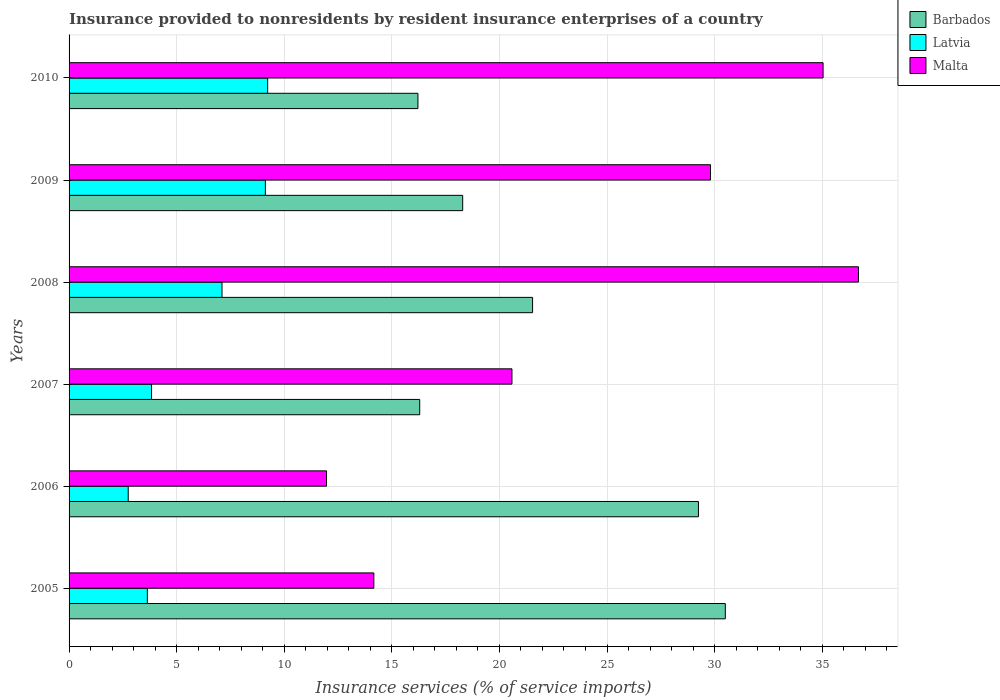How many different coloured bars are there?
Offer a terse response. 3. What is the insurance provided to nonresidents in Barbados in 2005?
Your response must be concise. 30.5. Across all years, what is the maximum insurance provided to nonresidents in Latvia?
Provide a succinct answer. 9.23. Across all years, what is the minimum insurance provided to nonresidents in Malta?
Keep it short and to the point. 11.96. What is the total insurance provided to nonresidents in Barbados in the graph?
Your answer should be compact. 132.09. What is the difference between the insurance provided to nonresidents in Malta in 2009 and that in 2010?
Provide a short and direct response. -5.23. What is the difference between the insurance provided to nonresidents in Latvia in 2008 and the insurance provided to nonresidents in Malta in 2007?
Offer a very short reply. -13.48. What is the average insurance provided to nonresidents in Barbados per year?
Your answer should be compact. 22.01. In the year 2005, what is the difference between the insurance provided to nonresidents in Barbados and insurance provided to nonresidents in Latvia?
Your answer should be very brief. 26.86. What is the ratio of the insurance provided to nonresidents in Malta in 2006 to that in 2008?
Your response must be concise. 0.33. Is the insurance provided to nonresidents in Malta in 2005 less than that in 2006?
Give a very brief answer. No. Is the difference between the insurance provided to nonresidents in Barbados in 2006 and 2010 greater than the difference between the insurance provided to nonresidents in Latvia in 2006 and 2010?
Keep it short and to the point. Yes. What is the difference between the highest and the second highest insurance provided to nonresidents in Malta?
Provide a succinct answer. 1.64. What is the difference between the highest and the lowest insurance provided to nonresidents in Latvia?
Ensure brevity in your answer.  6.48. In how many years, is the insurance provided to nonresidents in Barbados greater than the average insurance provided to nonresidents in Barbados taken over all years?
Offer a very short reply. 2. Is the sum of the insurance provided to nonresidents in Malta in 2006 and 2009 greater than the maximum insurance provided to nonresidents in Latvia across all years?
Your answer should be compact. Yes. What does the 2nd bar from the top in 2009 represents?
Make the answer very short. Latvia. What does the 1st bar from the bottom in 2010 represents?
Your response must be concise. Barbados. Is it the case that in every year, the sum of the insurance provided to nonresidents in Barbados and insurance provided to nonresidents in Malta is greater than the insurance provided to nonresidents in Latvia?
Make the answer very short. Yes. Are all the bars in the graph horizontal?
Make the answer very short. Yes. What is the difference between two consecutive major ticks on the X-axis?
Provide a short and direct response. 5. Does the graph contain any zero values?
Offer a terse response. No. Where does the legend appear in the graph?
Offer a terse response. Top right. How many legend labels are there?
Your response must be concise. 3. How are the legend labels stacked?
Offer a very short reply. Vertical. What is the title of the graph?
Offer a terse response. Insurance provided to nonresidents by resident insurance enterprises of a country. What is the label or title of the X-axis?
Make the answer very short. Insurance services (% of service imports). What is the label or title of the Y-axis?
Offer a terse response. Years. What is the Insurance services (% of service imports) of Barbados in 2005?
Offer a terse response. 30.5. What is the Insurance services (% of service imports) in Latvia in 2005?
Make the answer very short. 3.64. What is the Insurance services (% of service imports) of Malta in 2005?
Your answer should be compact. 14.16. What is the Insurance services (% of service imports) of Barbados in 2006?
Provide a succinct answer. 29.25. What is the Insurance services (% of service imports) in Latvia in 2006?
Your response must be concise. 2.75. What is the Insurance services (% of service imports) of Malta in 2006?
Your answer should be very brief. 11.96. What is the Insurance services (% of service imports) of Barbados in 2007?
Your answer should be very brief. 16.3. What is the Insurance services (% of service imports) of Latvia in 2007?
Keep it short and to the point. 3.83. What is the Insurance services (% of service imports) of Malta in 2007?
Your answer should be compact. 20.58. What is the Insurance services (% of service imports) of Barbados in 2008?
Your answer should be very brief. 21.54. What is the Insurance services (% of service imports) in Latvia in 2008?
Ensure brevity in your answer.  7.11. What is the Insurance services (% of service imports) in Malta in 2008?
Offer a very short reply. 36.69. What is the Insurance services (% of service imports) of Barbados in 2009?
Your response must be concise. 18.29. What is the Insurance services (% of service imports) in Latvia in 2009?
Offer a very short reply. 9.12. What is the Insurance services (% of service imports) of Malta in 2009?
Your answer should be compact. 29.81. What is the Insurance services (% of service imports) in Barbados in 2010?
Provide a short and direct response. 16.21. What is the Insurance services (% of service imports) of Latvia in 2010?
Give a very brief answer. 9.23. What is the Insurance services (% of service imports) in Malta in 2010?
Your response must be concise. 35.04. Across all years, what is the maximum Insurance services (% of service imports) of Barbados?
Your answer should be very brief. 30.5. Across all years, what is the maximum Insurance services (% of service imports) of Latvia?
Your answer should be compact. 9.23. Across all years, what is the maximum Insurance services (% of service imports) of Malta?
Keep it short and to the point. 36.69. Across all years, what is the minimum Insurance services (% of service imports) of Barbados?
Offer a very short reply. 16.21. Across all years, what is the minimum Insurance services (% of service imports) of Latvia?
Your response must be concise. 2.75. Across all years, what is the minimum Insurance services (% of service imports) in Malta?
Ensure brevity in your answer.  11.96. What is the total Insurance services (% of service imports) in Barbados in the graph?
Ensure brevity in your answer.  132.09. What is the total Insurance services (% of service imports) of Latvia in the graph?
Give a very brief answer. 35.68. What is the total Insurance services (% of service imports) in Malta in the graph?
Make the answer very short. 148.25. What is the difference between the Insurance services (% of service imports) of Barbados in 2005 and that in 2006?
Your answer should be very brief. 1.25. What is the difference between the Insurance services (% of service imports) of Latvia in 2005 and that in 2006?
Your answer should be very brief. 0.89. What is the difference between the Insurance services (% of service imports) in Malta in 2005 and that in 2006?
Your answer should be very brief. 2.2. What is the difference between the Insurance services (% of service imports) in Barbados in 2005 and that in 2007?
Offer a terse response. 14.2. What is the difference between the Insurance services (% of service imports) of Latvia in 2005 and that in 2007?
Keep it short and to the point. -0.2. What is the difference between the Insurance services (% of service imports) of Malta in 2005 and that in 2007?
Offer a terse response. -6.42. What is the difference between the Insurance services (% of service imports) in Barbados in 2005 and that in 2008?
Ensure brevity in your answer.  8.96. What is the difference between the Insurance services (% of service imports) of Latvia in 2005 and that in 2008?
Your answer should be compact. -3.47. What is the difference between the Insurance services (% of service imports) in Malta in 2005 and that in 2008?
Ensure brevity in your answer.  -22.52. What is the difference between the Insurance services (% of service imports) in Barbados in 2005 and that in 2009?
Your answer should be very brief. 12.21. What is the difference between the Insurance services (% of service imports) in Latvia in 2005 and that in 2009?
Ensure brevity in your answer.  -5.49. What is the difference between the Insurance services (% of service imports) in Malta in 2005 and that in 2009?
Keep it short and to the point. -15.64. What is the difference between the Insurance services (% of service imports) of Barbados in 2005 and that in 2010?
Give a very brief answer. 14.28. What is the difference between the Insurance services (% of service imports) of Latvia in 2005 and that in 2010?
Your answer should be compact. -5.59. What is the difference between the Insurance services (% of service imports) of Malta in 2005 and that in 2010?
Your answer should be very brief. -20.88. What is the difference between the Insurance services (% of service imports) of Barbados in 2006 and that in 2007?
Your answer should be very brief. 12.95. What is the difference between the Insurance services (% of service imports) of Latvia in 2006 and that in 2007?
Ensure brevity in your answer.  -1.08. What is the difference between the Insurance services (% of service imports) in Malta in 2006 and that in 2007?
Keep it short and to the point. -8.62. What is the difference between the Insurance services (% of service imports) of Barbados in 2006 and that in 2008?
Give a very brief answer. 7.71. What is the difference between the Insurance services (% of service imports) of Latvia in 2006 and that in 2008?
Keep it short and to the point. -4.36. What is the difference between the Insurance services (% of service imports) in Malta in 2006 and that in 2008?
Offer a terse response. -24.72. What is the difference between the Insurance services (% of service imports) in Barbados in 2006 and that in 2009?
Give a very brief answer. 10.96. What is the difference between the Insurance services (% of service imports) of Latvia in 2006 and that in 2009?
Keep it short and to the point. -6.37. What is the difference between the Insurance services (% of service imports) of Malta in 2006 and that in 2009?
Your answer should be very brief. -17.84. What is the difference between the Insurance services (% of service imports) in Barbados in 2006 and that in 2010?
Provide a succinct answer. 13.04. What is the difference between the Insurance services (% of service imports) in Latvia in 2006 and that in 2010?
Ensure brevity in your answer.  -6.48. What is the difference between the Insurance services (% of service imports) in Malta in 2006 and that in 2010?
Provide a short and direct response. -23.08. What is the difference between the Insurance services (% of service imports) of Barbados in 2007 and that in 2008?
Ensure brevity in your answer.  -5.24. What is the difference between the Insurance services (% of service imports) in Latvia in 2007 and that in 2008?
Give a very brief answer. -3.27. What is the difference between the Insurance services (% of service imports) in Malta in 2007 and that in 2008?
Ensure brevity in your answer.  -16.1. What is the difference between the Insurance services (% of service imports) in Barbados in 2007 and that in 2009?
Ensure brevity in your answer.  -2. What is the difference between the Insurance services (% of service imports) in Latvia in 2007 and that in 2009?
Your answer should be compact. -5.29. What is the difference between the Insurance services (% of service imports) of Malta in 2007 and that in 2009?
Offer a terse response. -9.23. What is the difference between the Insurance services (% of service imports) in Barbados in 2007 and that in 2010?
Your response must be concise. 0.08. What is the difference between the Insurance services (% of service imports) of Latvia in 2007 and that in 2010?
Your answer should be very brief. -5.4. What is the difference between the Insurance services (% of service imports) of Malta in 2007 and that in 2010?
Ensure brevity in your answer.  -14.46. What is the difference between the Insurance services (% of service imports) of Barbados in 2008 and that in 2009?
Give a very brief answer. 3.25. What is the difference between the Insurance services (% of service imports) in Latvia in 2008 and that in 2009?
Give a very brief answer. -2.02. What is the difference between the Insurance services (% of service imports) of Malta in 2008 and that in 2009?
Ensure brevity in your answer.  6.88. What is the difference between the Insurance services (% of service imports) in Barbados in 2008 and that in 2010?
Your response must be concise. 5.33. What is the difference between the Insurance services (% of service imports) of Latvia in 2008 and that in 2010?
Provide a succinct answer. -2.12. What is the difference between the Insurance services (% of service imports) of Malta in 2008 and that in 2010?
Make the answer very short. 1.64. What is the difference between the Insurance services (% of service imports) of Barbados in 2009 and that in 2010?
Give a very brief answer. 2.08. What is the difference between the Insurance services (% of service imports) in Latvia in 2009 and that in 2010?
Your answer should be very brief. -0.11. What is the difference between the Insurance services (% of service imports) in Malta in 2009 and that in 2010?
Your answer should be very brief. -5.23. What is the difference between the Insurance services (% of service imports) in Barbados in 2005 and the Insurance services (% of service imports) in Latvia in 2006?
Provide a succinct answer. 27.75. What is the difference between the Insurance services (% of service imports) in Barbados in 2005 and the Insurance services (% of service imports) in Malta in 2006?
Your answer should be very brief. 18.53. What is the difference between the Insurance services (% of service imports) in Latvia in 2005 and the Insurance services (% of service imports) in Malta in 2006?
Make the answer very short. -8.33. What is the difference between the Insurance services (% of service imports) of Barbados in 2005 and the Insurance services (% of service imports) of Latvia in 2007?
Your answer should be compact. 26.67. What is the difference between the Insurance services (% of service imports) of Barbados in 2005 and the Insurance services (% of service imports) of Malta in 2007?
Provide a short and direct response. 9.92. What is the difference between the Insurance services (% of service imports) of Latvia in 2005 and the Insurance services (% of service imports) of Malta in 2007?
Make the answer very short. -16.94. What is the difference between the Insurance services (% of service imports) of Barbados in 2005 and the Insurance services (% of service imports) of Latvia in 2008?
Your answer should be very brief. 23.39. What is the difference between the Insurance services (% of service imports) of Barbados in 2005 and the Insurance services (% of service imports) of Malta in 2008?
Your response must be concise. -6.19. What is the difference between the Insurance services (% of service imports) in Latvia in 2005 and the Insurance services (% of service imports) in Malta in 2008?
Offer a very short reply. -33.05. What is the difference between the Insurance services (% of service imports) in Barbados in 2005 and the Insurance services (% of service imports) in Latvia in 2009?
Make the answer very short. 21.38. What is the difference between the Insurance services (% of service imports) of Barbados in 2005 and the Insurance services (% of service imports) of Malta in 2009?
Your answer should be compact. 0.69. What is the difference between the Insurance services (% of service imports) in Latvia in 2005 and the Insurance services (% of service imports) in Malta in 2009?
Provide a succinct answer. -26.17. What is the difference between the Insurance services (% of service imports) in Barbados in 2005 and the Insurance services (% of service imports) in Latvia in 2010?
Provide a succinct answer. 21.27. What is the difference between the Insurance services (% of service imports) in Barbados in 2005 and the Insurance services (% of service imports) in Malta in 2010?
Your answer should be very brief. -4.54. What is the difference between the Insurance services (% of service imports) in Latvia in 2005 and the Insurance services (% of service imports) in Malta in 2010?
Ensure brevity in your answer.  -31.4. What is the difference between the Insurance services (% of service imports) of Barbados in 2006 and the Insurance services (% of service imports) of Latvia in 2007?
Provide a short and direct response. 25.42. What is the difference between the Insurance services (% of service imports) in Barbados in 2006 and the Insurance services (% of service imports) in Malta in 2007?
Your answer should be very brief. 8.67. What is the difference between the Insurance services (% of service imports) in Latvia in 2006 and the Insurance services (% of service imports) in Malta in 2007?
Offer a terse response. -17.83. What is the difference between the Insurance services (% of service imports) in Barbados in 2006 and the Insurance services (% of service imports) in Latvia in 2008?
Your answer should be very brief. 22.14. What is the difference between the Insurance services (% of service imports) in Barbados in 2006 and the Insurance services (% of service imports) in Malta in 2008?
Provide a succinct answer. -7.44. What is the difference between the Insurance services (% of service imports) of Latvia in 2006 and the Insurance services (% of service imports) of Malta in 2008?
Give a very brief answer. -33.94. What is the difference between the Insurance services (% of service imports) in Barbados in 2006 and the Insurance services (% of service imports) in Latvia in 2009?
Your answer should be very brief. 20.13. What is the difference between the Insurance services (% of service imports) in Barbados in 2006 and the Insurance services (% of service imports) in Malta in 2009?
Your answer should be compact. -0.56. What is the difference between the Insurance services (% of service imports) of Latvia in 2006 and the Insurance services (% of service imports) of Malta in 2009?
Your response must be concise. -27.06. What is the difference between the Insurance services (% of service imports) in Barbados in 2006 and the Insurance services (% of service imports) in Latvia in 2010?
Give a very brief answer. 20.02. What is the difference between the Insurance services (% of service imports) in Barbados in 2006 and the Insurance services (% of service imports) in Malta in 2010?
Provide a short and direct response. -5.79. What is the difference between the Insurance services (% of service imports) of Latvia in 2006 and the Insurance services (% of service imports) of Malta in 2010?
Give a very brief answer. -32.29. What is the difference between the Insurance services (% of service imports) in Barbados in 2007 and the Insurance services (% of service imports) in Latvia in 2008?
Offer a terse response. 9.19. What is the difference between the Insurance services (% of service imports) in Barbados in 2007 and the Insurance services (% of service imports) in Malta in 2008?
Provide a succinct answer. -20.39. What is the difference between the Insurance services (% of service imports) in Latvia in 2007 and the Insurance services (% of service imports) in Malta in 2008?
Keep it short and to the point. -32.85. What is the difference between the Insurance services (% of service imports) of Barbados in 2007 and the Insurance services (% of service imports) of Latvia in 2009?
Provide a short and direct response. 7.17. What is the difference between the Insurance services (% of service imports) of Barbados in 2007 and the Insurance services (% of service imports) of Malta in 2009?
Provide a short and direct response. -13.51. What is the difference between the Insurance services (% of service imports) of Latvia in 2007 and the Insurance services (% of service imports) of Malta in 2009?
Ensure brevity in your answer.  -25.98. What is the difference between the Insurance services (% of service imports) in Barbados in 2007 and the Insurance services (% of service imports) in Latvia in 2010?
Provide a short and direct response. 7.07. What is the difference between the Insurance services (% of service imports) of Barbados in 2007 and the Insurance services (% of service imports) of Malta in 2010?
Give a very brief answer. -18.75. What is the difference between the Insurance services (% of service imports) in Latvia in 2007 and the Insurance services (% of service imports) in Malta in 2010?
Your response must be concise. -31.21. What is the difference between the Insurance services (% of service imports) of Barbados in 2008 and the Insurance services (% of service imports) of Latvia in 2009?
Your response must be concise. 12.42. What is the difference between the Insurance services (% of service imports) in Barbados in 2008 and the Insurance services (% of service imports) in Malta in 2009?
Provide a succinct answer. -8.27. What is the difference between the Insurance services (% of service imports) of Latvia in 2008 and the Insurance services (% of service imports) of Malta in 2009?
Provide a succinct answer. -22.7. What is the difference between the Insurance services (% of service imports) of Barbados in 2008 and the Insurance services (% of service imports) of Latvia in 2010?
Your response must be concise. 12.31. What is the difference between the Insurance services (% of service imports) of Barbados in 2008 and the Insurance services (% of service imports) of Malta in 2010?
Provide a succinct answer. -13.5. What is the difference between the Insurance services (% of service imports) of Latvia in 2008 and the Insurance services (% of service imports) of Malta in 2010?
Your answer should be compact. -27.93. What is the difference between the Insurance services (% of service imports) in Barbados in 2009 and the Insurance services (% of service imports) in Latvia in 2010?
Provide a succinct answer. 9.06. What is the difference between the Insurance services (% of service imports) of Barbados in 2009 and the Insurance services (% of service imports) of Malta in 2010?
Provide a short and direct response. -16.75. What is the difference between the Insurance services (% of service imports) in Latvia in 2009 and the Insurance services (% of service imports) in Malta in 2010?
Your response must be concise. -25.92. What is the average Insurance services (% of service imports) of Barbados per year?
Give a very brief answer. 22.01. What is the average Insurance services (% of service imports) of Latvia per year?
Give a very brief answer. 5.95. What is the average Insurance services (% of service imports) of Malta per year?
Provide a short and direct response. 24.71. In the year 2005, what is the difference between the Insurance services (% of service imports) in Barbados and Insurance services (% of service imports) in Latvia?
Make the answer very short. 26.86. In the year 2005, what is the difference between the Insurance services (% of service imports) of Barbados and Insurance services (% of service imports) of Malta?
Your answer should be compact. 16.33. In the year 2005, what is the difference between the Insurance services (% of service imports) in Latvia and Insurance services (% of service imports) in Malta?
Make the answer very short. -10.53. In the year 2006, what is the difference between the Insurance services (% of service imports) of Barbados and Insurance services (% of service imports) of Latvia?
Ensure brevity in your answer.  26.5. In the year 2006, what is the difference between the Insurance services (% of service imports) in Barbados and Insurance services (% of service imports) in Malta?
Keep it short and to the point. 17.28. In the year 2006, what is the difference between the Insurance services (% of service imports) in Latvia and Insurance services (% of service imports) in Malta?
Offer a terse response. -9.22. In the year 2007, what is the difference between the Insurance services (% of service imports) of Barbados and Insurance services (% of service imports) of Latvia?
Offer a very short reply. 12.46. In the year 2007, what is the difference between the Insurance services (% of service imports) of Barbados and Insurance services (% of service imports) of Malta?
Your response must be concise. -4.29. In the year 2007, what is the difference between the Insurance services (% of service imports) of Latvia and Insurance services (% of service imports) of Malta?
Make the answer very short. -16.75. In the year 2008, what is the difference between the Insurance services (% of service imports) of Barbados and Insurance services (% of service imports) of Latvia?
Your response must be concise. 14.43. In the year 2008, what is the difference between the Insurance services (% of service imports) in Barbados and Insurance services (% of service imports) in Malta?
Offer a very short reply. -15.15. In the year 2008, what is the difference between the Insurance services (% of service imports) of Latvia and Insurance services (% of service imports) of Malta?
Ensure brevity in your answer.  -29.58. In the year 2009, what is the difference between the Insurance services (% of service imports) in Barbados and Insurance services (% of service imports) in Latvia?
Ensure brevity in your answer.  9.17. In the year 2009, what is the difference between the Insurance services (% of service imports) of Barbados and Insurance services (% of service imports) of Malta?
Provide a succinct answer. -11.52. In the year 2009, what is the difference between the Insurance services (% of service imports) in Latvia and Insurance services (% of service imports) in Malta?
Keep it short and to the point. -20.69. In the year 2010, what is the difference between the Insurance services (% of service imports) in Barbados and Insurance services (% of service imports) in Latvia?
Provide a short and direct response. 6.98. In the year 2010, what is the difference between the Insurance services (% of service imports) in Barbados and Insurance services (% of service imports) in Malta?
Make the answer very short. -18.83. In the year 2010, what is the difference between the Insurance services (% of service imports) in Latvia and Insurance services (% of service imports) in Malta?
Offer a terse response. -25.81. What is the ratio of the Insurance services (% of service imports) in Barbados in 2005 to that in 2006?
Offer a terse response. 1.04. What is the ratio of the Insurance services (% of service imports) of Latvia in 2005 to that in 2006?
Offer a very short reply. 1.32. What is the ratio of the Insurance services (% of service imports) in Malta in 2005 to that in 2006?
Your answer should be compact. 1.18. What is the ratio of the Insurance services (% of service imports) of Barbados in 2005 to that in 2007?
Make the answer very short. 1.87. What is the ratio of the Insurance services (% of service imports) of Latvia in 2005 to that in 2007?
Provide a short and direct response. 0.95. What is the ratio of the Insurance services (% of service imports) of Malta in 2005 to that in 2007?
Offer a terse response. 0.69. What is the ratio of the Insurance services (% of service imports) in Barbados in 2005 to that in 2008?
Provide a succinct answer. 1.42. What is the ratio of the Insurance services (% of service imports) of Latvia in 2005 to that in 2008?
Provide a short and direct response. 0.51. What is the ratio of the Insurance services (% of service imports) of Malta in 2005 to that in 2008?
Your answer should be compact. 0.39. What is the ratio of the Insurance services (% of service imports) in Barbados in 2005 to that in 2009?
Give a very brief answer. 1.67. What is the ratio of the Insurance services (% of service imports) in Latvia in 2005 to that in 2009?
Give a very brief answer. 0.4. What is the ratio of the Insurance services (% of service imports) of Malta in 2005 to that in 2009?
Your answer should be compact. 0.48. What is the ratio of the Insurance services (% of service imports) of Barbados in 2005 to that in 2010?
Provide a short and direct response. 1.88. What is the ratio of the Insurance services (% of service imports) of Latvia in 2005 to that in 2010?
Offer a very short reply. 0.39. What is the ratio of the Insurance services (% of service imports) of Malta in 2005 to that in 2010?
Ensure brevity in your answer.  0.4. What is the ratio of the Insurance services (% of service imports) of Barbados in 2006 to that in 2007?
Offer a very short reply. 1.79. What is the ratio of the Insurance services (% of service imports) in Latvia in 2006 to that in 2007?
Provide a short and direct response. 0.72. What is the ratio of the Insurance services (% of service imports) of Malta in 2006 to that in 2007?
Provide a short and direct response. 0.58. What is the ratio of the Insurance services (% of service imports) in Barbados in 2006 to that in 2008?
Provide a succinct answer. 1.36. What is the ratio of the Insurance services (% of service imports) of Latvia in 2006 to that in 2008?
Ensure brevity in your answer.  0.39. What is the ratio of the Insurance services (% of service imports) of Malta in 2006 to that in 2008?
Offer a very short reply. 0.33. What is the ratio of the Insurance services (% of service imports) in Barbados in 2006 to that in 2009?
Your answer should be compact. 1.6. What is the ratio of the Insurance services (% of service imports) in Latvia in 2006 to that in 2009?
Offer a very short reply. 0.3. What is the ratio of the Insurance services (% of service imports) of Malta in 2006 to that in 2009?
Offer a terse response. 0.4. What is the ratio of the Insurance services (% of service imports) in Barbados in 2006 to that in 2010?
Your answer should be compact. 1.8. What is the ratio of the Insurance services (% of service imports) in Latvia in 2006 to that in 2010?
Keep it short and to the point. 0.3. What is the ratio of the Insurance services (% of service imports) of Malta in 2006 to that in 2010?
Offer a very short reply. 0.34. What is the ratio of the Insurance services (% of service imports) in Barbados in 2007 to that in 2008?
Your response must be concise. 0.76. What is the ratio of the Insurance services (% of service imports) of Latvia in 2007 to that in 2008?
Provide a short and direct response. 0.54. What is the ratio of the Insurance services (% of service imports) of Malta in 2007 to that in 2008?
Your answer should be compact. 0.56. What is the ratio of the Insurance services (% of service imports) of Barbados in 2007 to that in 2009?
Provide a succinct answer. 0.89. What is the ratio of the Insurance services (% of service imports) in Latvia in 2007 to that in 2009?
Provide a short and direct response. 0.42. What is the ratio of the Insurance services (% of service imports) of Malta in 2007 to that in 2009?
Your answer should be very brief. 0.69. What is the ratio of the Insurance services (% of service imports) in Barbados in 2007 to that in 2010?
Provide a short and direct response. 1.01. What is the ratio of the Insurance services (% of service imports) of Latvia in 2007 to that in 2010?
Your answer should be compact. 0.42. What is the ratio of the Insurance services (% of service imports) of Malta in 2007 to that in 2010?
Offer a terse response. 0.59. What is the ratio of the Insurance services (% of service imports) in Barbados in 2008 to that in 2009?
Your answer should be very brief. 1.18. What is the ratio of the Insurance services (% of service imports) of Latvia in 2008 to that in 2009?
Offer a very short reply. 0.78. What is the ratio of the Insurance services (% of service imports) in Malta in 2008 to that in 2009?
Your answer should be compact. 1.23. What is the ratio of the Insurance services (% of service imports) of Barbados in 2008 to that in 2010?
Offer a very short reply. 1.33. What is the ratio of the Insurance services (% of service imports) in Latvia in 2008 to that in 2010?
Your answer should be very brief. 0.77. What is the ratio of the Insurance services (% of service imports) in Malta in 2008 to that in 2010?
Ensure brevity in your answer.  1.05. What is the ratio of the Insurance services (% of service imports) in Barbados in 2009 to that in 2010?
Offer a very short reply. 1.13. What is the ratio of the Insurance services (% of service imports) of Malta in 2009 to that in 2010?
Ensure brevity in your answer.  0.85. What is the difference between the highest and the second highest Insurance services (% of service imports) in Barbados?
Give a very brief answer. 1.25. What is the difference between the highest and the second highest Insurance services (% of service imports) in Latvia?
Your answer should be very brief. 0.11. What is the difference between the highest and the second highest Insurance services (% of service imports) of Malta?
Your answer should be compact. 1.64. What is the difference between the highest and the lowest Insurance services (% of service imports) in Barbados?
Offer a very short reply. 14.28. What is the difference between the highest and the lowest Insurance services (% of service imports) in Latvia?
Your answer should be very brief. 6.48. What is the difference between the highest and the lowest Insurance services (% of service imports) in Malta?
Provide a succinct answer. 24.72. 